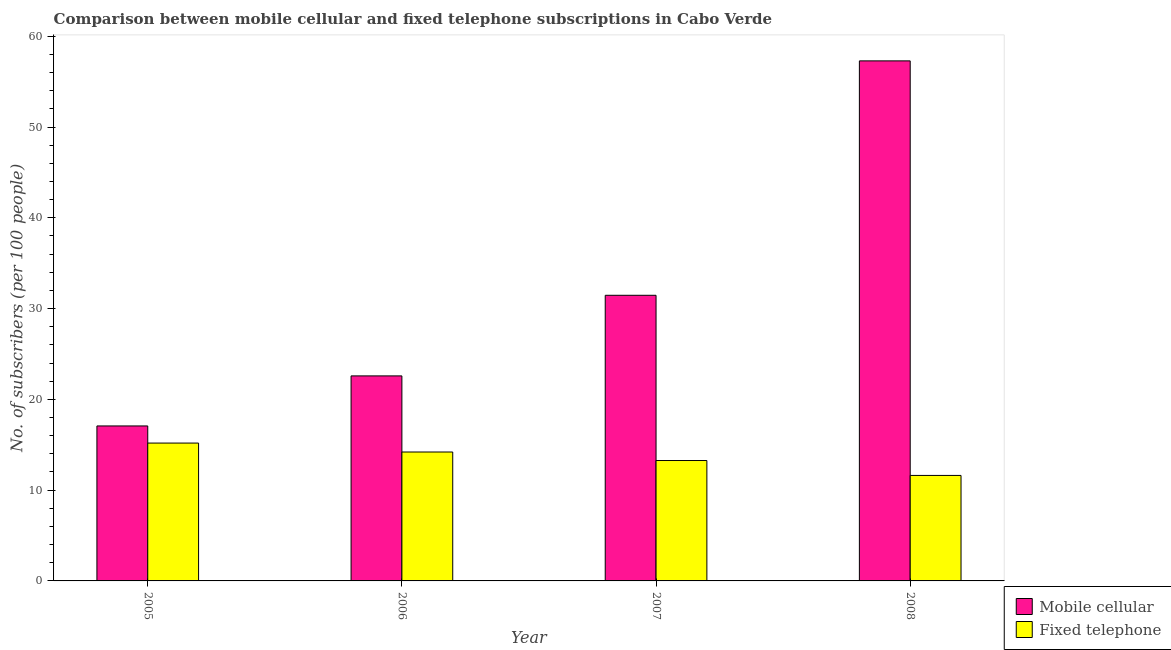How many groups of bars are there?
Your response must be concise. 4. Are the number of bars per tick equal to the number of legend labels?
Make the answer very short. Yes. Are the number of bars on each tick of the X-axis equal?
Your answer should be very brief. Yes. How many bars are there on the 2nd tick from the right?
Keep it short and to the point. 2. What is the number of mobile cellular subscribers in 2006?
Give a very brief answer. 22.59. Across all years, what is the maximum number of fixed telephone subscribers?
Give a very brief answer. 15.19. Across all years, what is the minimum number of mobile cellular subscribers?
Offer a very short reply. 17.07. In which year was the number of mobile cellular subscribers maximum?
Your answer should be compact. 2008. In which year was the number of mobile cellular subscribers minimum?
Give a very brief answer. 2005. What is the total number of mobile cellular subscribers in the graph?
Ensure brevity in your answer.  128.42. What is the difference between the number of fixed telephone subscribers in 2006 and that in 2007?
Your response must be concise. 0.94. What is the difference between the number of mobile cellular subscribers in 2005 and the number of fixed telephone subscribers in 2007?
Keep it short and to the point. -14.39. What is the average number of mobile cellular subscribers per year?
Provide a short and direct response. 32.11. What is the ratio of the number of fixed telephone subscribers in 2006 to that in 2008?
Give a very brief answer. 1.22. Is the number of fixed telephone subscribers in 2007 less than that in 2008?
Your answer should be very brief. No. What is the difference between the highest and the second highest number of fixed telephone subscribers?
Your answer should be very brief. 0.98. What is the difference between the highest and the lowest number of mobile cellular subscribers?
Ensure brevity in your answer.  40.22. What does the 1st bar from the left in 2006 represents?
Provide a succinct answer. Mobile cellular. What does the 1st bar from the right in 2006 represents?
Your answer should be very brief. Fixed telephone. How many bars are there?
Your answer should be compact. 8. Does the graph contain any zero values?
Your answer should be compact. No. How are the legend labels stacked?
Your answer should be very brief. Vertical. What is the title of the graph?
Ensure brevity in your answer.  Comparison between mobile cellular and fixed telephone subscriptions in Cabo Verde. Does "Official aid received" appear as one of the legend labels in the graph?
Offer a terse response. No. What is the label or title of the Y-axis?
Provide a short and direct response. No. of subscribers (per 100 people). What is the No. of subscribers (per 100 people) of Mobile cellular in 2005?
Offer a terse response. 17.07. What is the No. of subscribers (per 100 people) of Fixed telephone in 2005?
Give a very brief answer. 15.19. What is the No. of subscribers (per 100 people) of Mobile cellular in 2006?
Make the answer very short. 22.59. What is the No. of subscribers (per 100 people) of Fixed telephone in 2006?
Provide a succinct answer. 14.2. What is the No. of subscribers (per 100 people) of Mobile cellular in 2007?
Keep it short and to the point. 31.47. What is the No. of subscribers (per 100 people) in Fixed telephone in 2007?
Keep it short and to the point. 13.26. What is the No. of subscribers (per 100 people) of Mobile cellular in 2008?
Offer a terse response. 57.29. What is the No. of subscribers (per 100 people) in Fixed telephone in 2008?
Make the answer very short. 11.62. Across all years, what is the maximum No. of subscribers (per 100 people) in Mobile cellular?
Provide a short and direct response. 57.29. Across all years, what is the maximum No. of subscribers (per 100 people) of Fixed telephone?
Provide a short and direct response. 15.19. Across all years, what is the minimum No. of subscribers (per 100 people) of Mobile cellular?
Offer a terse response. 17.07. Across all years, what is the minimum No. of subscribers (per 100 people) of Fixed telephone?
Keep it short and to the point. 11.62. What is the total No. of subscribers (per 100 people) in Mobile cellular in the graph?
Keep it short and to the point. 128.42. What is the total No. of subscribers (per 100 people) in Fixed telephone in the graph?
Offer a very short reply. 54.28. What is the difference between the No. of subscribers (per 100 people) of Mobile cellular in 2005 and that in 2006?
Offer a terse response. -5.51. What is the difference between the No. of subscribers (per 100 people) in Fixed telephone in 2005 and that in 2006?
Offer a terse response. 0.98. What is the difference between the No. of subscribers (per 100 people) of Mobile cellular in 2005 and that in 2007?
Your answer should be very brief. -14.39. What is the difference between the No. of subscribers (per 100 people) of Fixed telephone in 2005 and that in 2007?
Ensure brevity in your answer.  1.92. What is the difference between the No. of subscribers (per 100 people) in Mobile cellular in 2005 and that in 2008?
Offer a very short reply. -40.22. What is the difference between the No. of subscribers (per 100 people) of Fixed telephone in 2005 and that in 2008?
Offer a terse response. 3.57. What is the difference between the No. of subscribers (per 100 people) in Mobile cellular in 2006 and that in 2007?
Offer a terse response. -8.88. What is the difference between the No. of subscribers (per 100 people) of Fixed telephone in 2006 and that in 2007?
Offer a terse response. 0.94. What is the difference between the No. of subscribers (per 100 people) in Mobile cellular in 2006 and that in 2008?
Your answer should be compact. -34.71. What is the difference between the No. of subscribers (per 100 people) in Fixed telephone in 2006 and that in 2008?
Your response must be concise. 2.58. What is the difference between the No. of subscribers (per 100 people) of Mobile cellular in 2007 and that in 2008?
Offer a terse response. -25.83. What is the difference between the No. of subscribers (per 100 people) in Fixed telephone in 2007 and that in 2008?
Ensure brevity in your answer.  1.64. What is the difference between the No. of subscribers (per 100 people) of Mobile cellular in 2005 and the No. of subscribers (per 100 people) of Fixed telephone in 2006?
Make the answer very short. 2.87. What is the difference between the No. of subscribers (per 100 people) in Mobile cellular in 2005 and the No. of subscribers (per 100 people) in Fixed telephone in 2007?
Your answer should be compact. 3.81. What is the difference between the No. of subscribers (per 100 people) in Mobile cellular in 2005 and the No. of subscribers (per 100 people) in Fixed telephone in 2008?
Provide a short and direct response. 5.45. What is the difference between the No. of subscribers (per 100 people) of Mobile cellular in 2006 and the No. of subscribers (per 100 people) of Fixed telephone in 2007?
Keep it short and to the point. 9.32. What is the difference between the No. of subscribers (per 100 people) in Mobile cellular in 2006 and the No. of subscribers (per 100 people) in Fixed telephone in 2008?
Ensure brevity in your answer.  10.97. What is the difference between the No. of subscribers (per 100 people) of Mobile cellular in 2007 and the No. of subscribers (per 100 people) of Fixed telephone in 2008?
Provide a short and direct response. 19.85. What is the average No. of subscribers (per 100 people) in Mobile cellular per year?
Your answer should be very brief. 32.11. What is the average No. of subscribers (per 100 people) in Fixed telephone per year?
Your response must be concise. 13.57. In the year 2005, what is the difference between the No. of subscribers (per 100 people) in Mobile cellular and No. of subscribers (per 100 people) in Fixed telephone?
Your response must be concise. 1.89. In the year 2006, what is the difference between the No. of subscribers (per 100 people) in Mobile cellular and No. of subscribers (per 100 people) in Fixed telephone?
Give a very brief answer. 8.38. In the year 2007, what is the difference between the No. of subscribers (per 100 people) of Mobile cellular and No. of subscribers (per 100 people) of Fixed telephone?
Offer a terse response. 18.2. In the year 2008, what is the difference between the No. of subscribers (per 100 people) of Mobile cellular and No. of subscribers (per 100 people) of Fixed telephone?
Provide a succinct answer. 45.67. What is the ratio of the No. of subscribers (per 100 people) in Mobile cellular in 2005 to that in 2006?
Your answer should be very brief. 0.76. What is the ratio of the No. of subscribers (per 100 people) in Fixed telephone in 2005 to that in 2006?
Offer a terse response. 1.07. What is the ratio of the No. of subscribers (per 100 people) in Mobile cellular in 2005 to that in 2007?
Keep it short and to the point. 0.54. What is the ratio of the No. of subscribers (per 100 people) in Fixed telephone in 2005 to that in 2007?
Provide a succinct answer. 1.15. What is the ratio of the No. of subscribers (per 100 people) of Mobile cellular in 2005 to that in 2008?
Your response must be concise. 0.3. What is the ratio of the No. of subscribers (per 100 people) of Fixed telephone in 2005 to that in 2008?
Offer a very short reply. 1.31. What is the ratio of the No. of subscribers (per 100 people) of Mobile cellular in 2006 to that in 2007?
Offer a very short reply. 0.72. What is the ratio of the No. of subscribers (per 100 people) in Fixed telephone in 2006 to that in 2007?
Your answer should be very brief. 1.07. What is the ratio of the No. of subscribers (per 100 people) of Mobile cellular in 2006 to that in 2008?
Your answer should be very brief. 0.39. What is the ratio of the No. of subscribers (per 100 people) of Fixed telephone in 2006 to that in 2008?
Provide a succinct answer. 1.22. What is the ratio of the No. of subscribers (per 100 people) of Mobile cellular in 2007 to that in 2008?
Your answer should be compact. 0.55. What is the ratio of the No. of subscribers (per 100 people) in Fixed telephone in 2007 to that in 2008?
Keep it short and to the point. 1.14. What is the difference between the highest and the second highest No. of subscribers (per 100 people) of Mobile cellular?
Give a very brief answer. 25.83. What is the difference between the highest and the second highest No. of subscribers (per 100 people) of Fixed telephone?
Your answer should be compact. 0.98. What is the difference between the highest and the lowest No. of subscribers (per 100 people) of Mobile cellular?
Provide a short and direct response. 40.22. What is the difference between the highest and the lowest No. of subscribers (per 100 people) of Fixed telephone?
Ensure brevity in your answer.  3.57. 